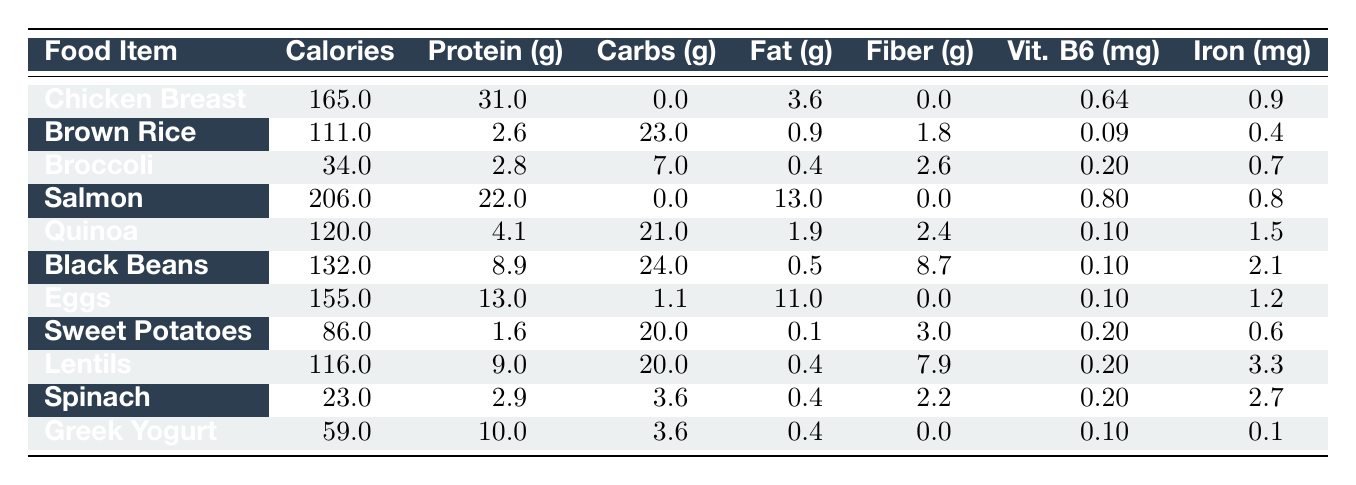What food item has the highest protein content? Looking at the protein content of each food item, Chicken Breast has the highest value at 31g per 100g serving.
Answer: Chicken Breast How many calories does a serving of Salmon contain? According to the table, a 100g serving of Salmon contains 206 calories.
Answer: 206 calories Which food contains the lowest fat content? Reviewing the fat column, Sweet Potatoes have the lowest fat content at 0.1g per 100g serving.
Answer: 0.1g What is the total carbohydrate content of Black Beans and Quinoa combined? To find the total carbohydrates, add the carbs from both foods: Black Beans (24g) + Quinoa (21g) = 45g.
Answer: 45g Does Greek Yogurt have more iron than Broccoli? Greek Yogurt contains 0.1mg of iron, while Broccoli has 0.7mg. Therefore, Greek Yogurt does not have more iron.
Answer: No What food has the least number of calories per 100g? By comparing the calorie contents, Spinach has the least at 23 calories per 100g serving.
Answer: Spinach Calculate the average protein content of Lentils, Black Beans, and Eggs. The protein contents are 9g (Lentils), 8.9g (Black Beans), and 13g (Eggs). The average is (9 + 8.9 + 13) / 3 = 10.3g.
Answer: 10.3g Which food items provide more than 2mg of iron? Looking at the iron content, Black Beans (2.1mg) and Lentils (3.3mg) both exceed 2mg of iron per 100g.
Answer: Black Beans and Lentils How many foods have a carbohydrate content greater than 20g? The food items with more than 20g of carbs are Brown Rice (23g), Black Beans (24g), Quinoa (21g), and Sweet Potatoes (20g, but not greater than). Thus, 3 foods exceed 20g.
Answer: 3 Is there more fiber in Eggs or Spinach? Eggs have 0g of fiber, while Spinach has 2.2g, making it clear that Spinach has more fiber.
Answer: Spinach What is the total vitamin B6 content from Chicken Breast and Salmon? Chicken Breast provides 0.64mg and Salmon 0.8mg. Adding these together gives a total of 1.44mg of vitamin B6.
Answer: 1.44mg 